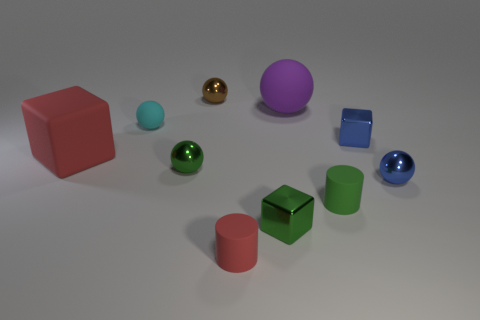Subtract all purple spheres. How many spheres are left? 4 Subtract all large balls. How many balls are left? 4 Subtract all gray balls. Subtract all blue cylinders. How many balls are left? 5 Subtract all cubes. How many objects are left? 7 Subtract all small metal cylinders. Subtract all small brown shiny objects. How many objects are left? 9 Add 5 large purple matte things. How many large purple matte things are left? 6 Add 2 blue rubber objects. How many blue rubber objects exist? 2 Subtract 1 red cubes. How many objects are left? 9 